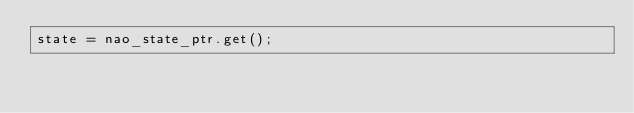Convert code to text. <code><loc_0><loc_0><loc_500><loc_500><_ObjectiveC_>state = nao_state_ptr.get();
</code> 